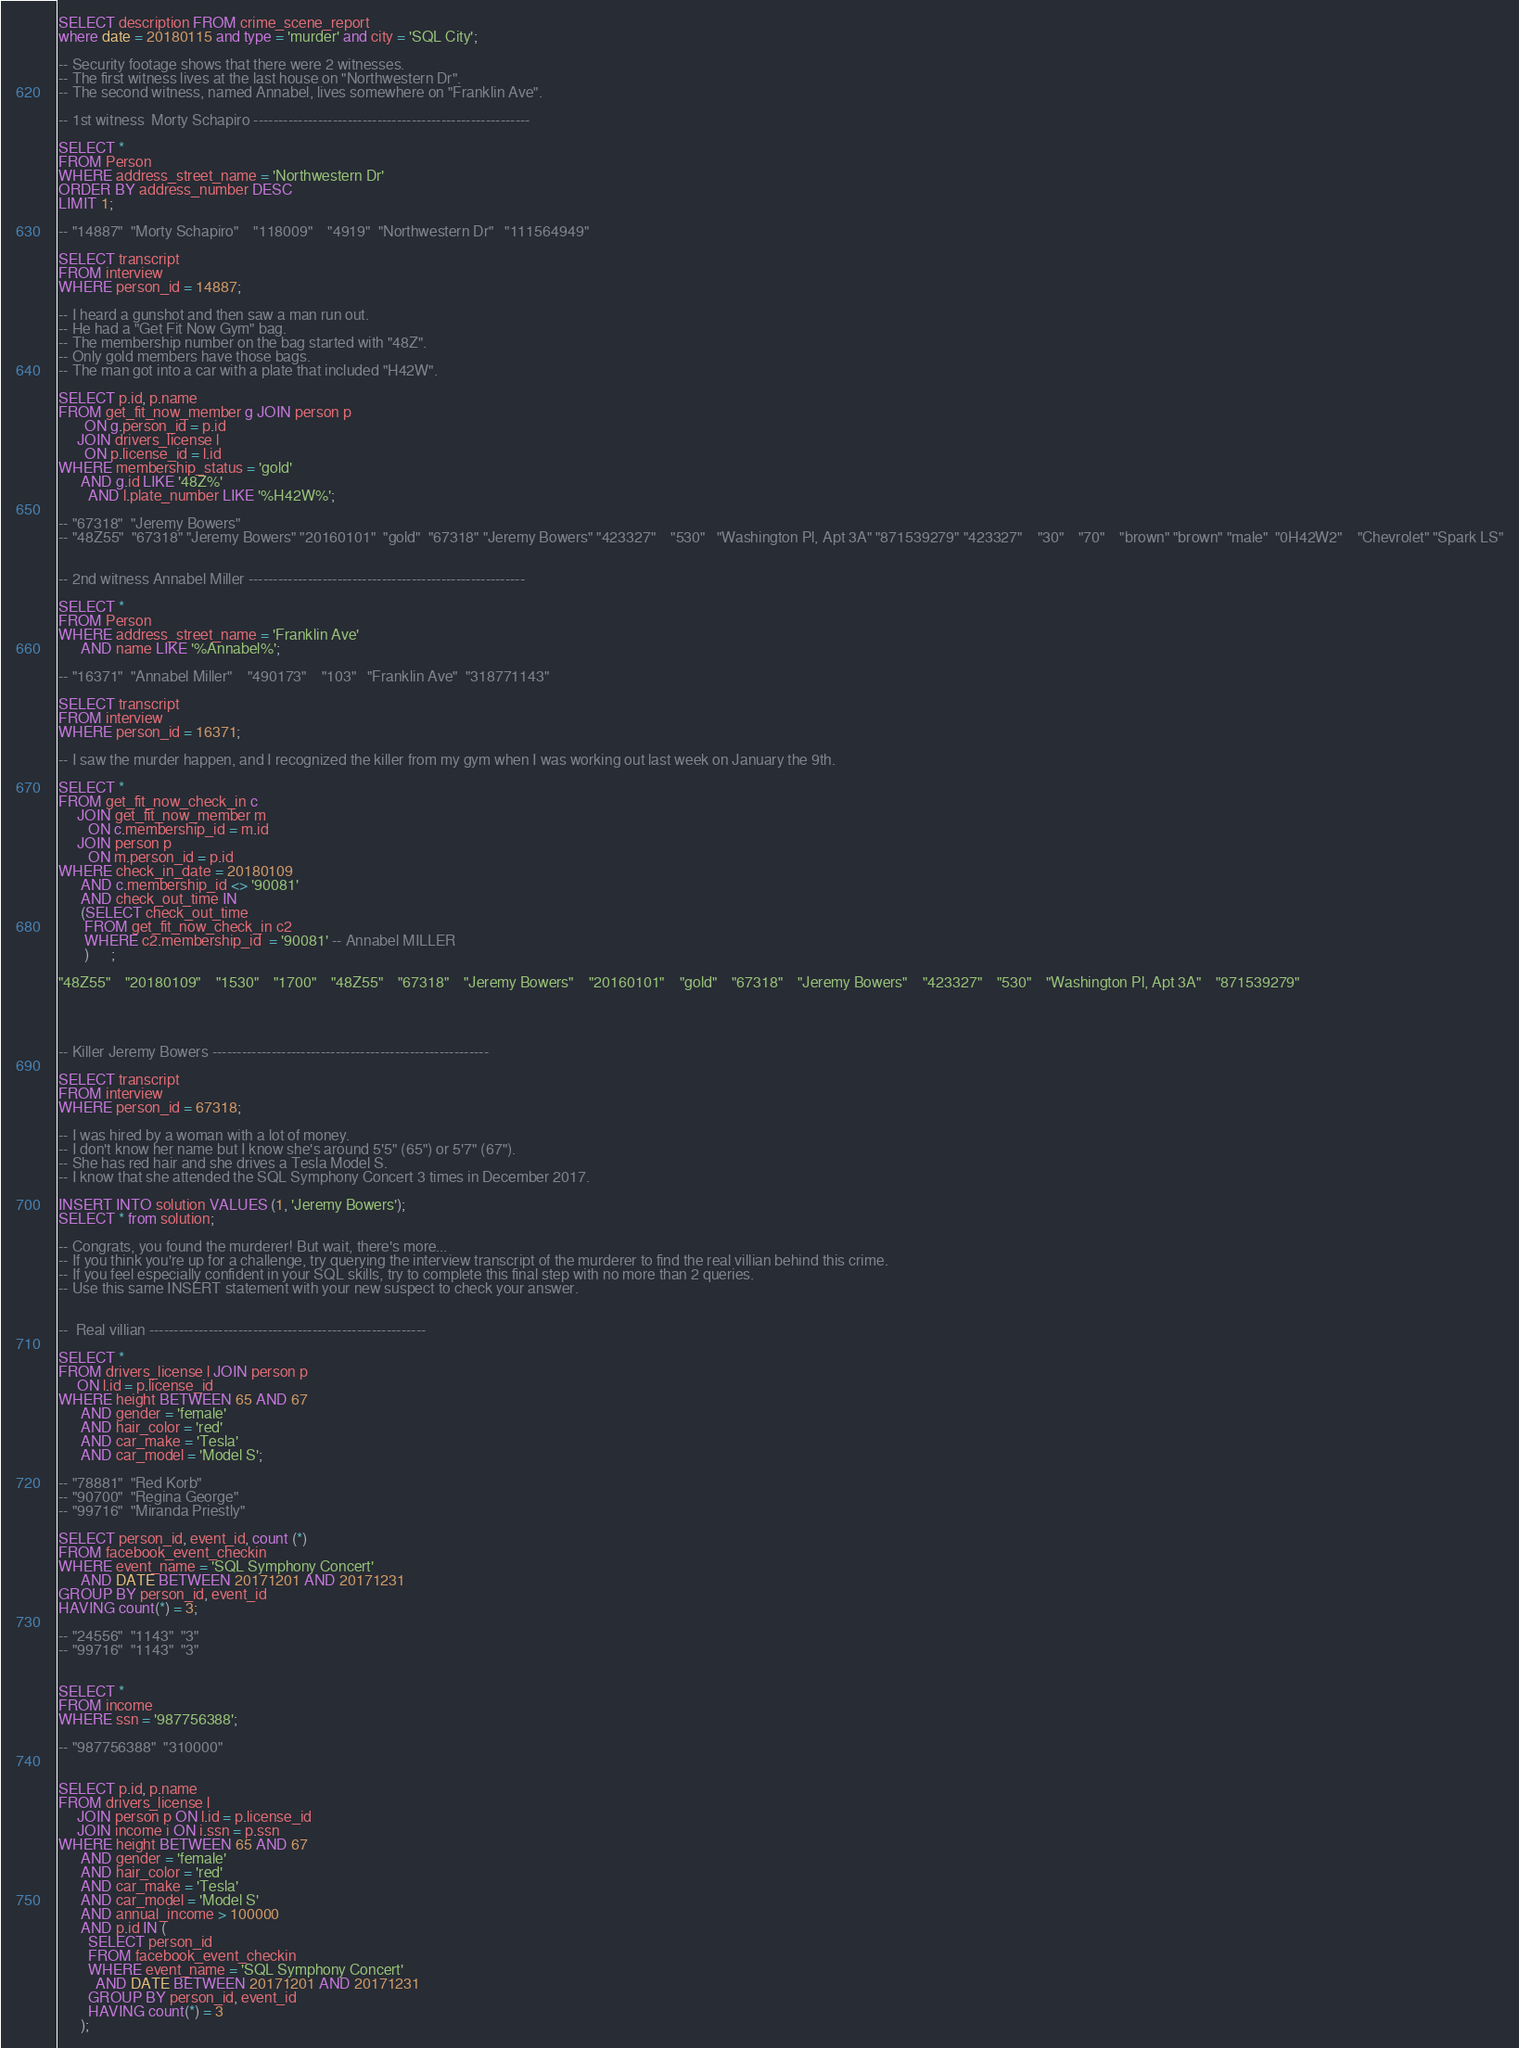<code> <loc_0><loc_0><loc_500><loc_500><_SQL_>SELECT description FROM crime_scene_report
where date = 20180115 and type = 'murder' and city = 'SQL City';

-- Security footage shows that there were 2 witnesses.
-- The first witness lives at the last house on "Northwestern Dr".
-- The second witness, named Annabel, lives somewhere on "Franklin Ave".

-- 1st witness  Morty Schapiro --------------------------------------------------------

SELECT * 
FROM Person
WHERE address_street_name = 'Northwestern Dr'
ORDER BY address_number DESC
LIMIT 1;

-- "14887"	"Morty Schapiro"	"118009"	"4919"	"Northwestern Dr"	"111564949"

SELECT transcript
FROM interview
WHERE person_id = 14887;

-- I heard a gunshot and then saw a man run out.
-- He had a "Get Fit Now Gym" bag.
-- The membership number on the bag started with "48Z".
-- Only gold members have those bags.
-- The man got into a car with a plate that included "H42W".

SELECT p.id, p.name
FROM get_fit_now_member g JOIN person p 
       ON g.person_id = p.id
	 JOIN drivers_license l 
       ON p.license_id = l.id
WHERE membership_status = 'gold'
      AND g.id LIKE '48Z%'
	    AND l.plate_number LIKE '%H42W%';

-- "67318"	"Jeremy Bowers"
-- "48Z55"	"67318"	"Jeremy Bowers"	"20160101"	"gold"	"67318"	"Jeremy Bowers"	"423327"	"530"	"Washington Pl, Apt 3A"	"871539279"	"423327"	"30"	"70"	"brown"	"brown"	"male"	"0H42W2"	"Chevrolet"	"Spark LS"


-- 2nd witness Annabel Miller --------------------------------------------------------

SELECT * 
FROM Person
WHERE address_street_name = 'Franklin Ave'
	  AND name LIKE '%Annabel%';
    
-- "16371"	"Annabel Miller"	"490173"	"103"	"Franklin Ave"	"318771143"

SELECT transcript
FROM interview
WHERE person_id = 16371;

-- I saw the murder happen, and I recognized the killer from my gym when I was working out last week on January the 9th.

SELECT *
FROM get_fit_now_check_in c
     JOIN get_fit_now_member m
		ON c.membership_id = m.id
     JOIN person p 
	    ON m.person_id = p.id
WHERE check_in_date = 20180109
      AND c.membership_id <> '90081'
      AND check_out_time IN 
	  (SELECT check_out_time
	   FROM get_fit_now_check_in c2
	   WHERE c2.membership_id  = '90081' -- Annabel MILLER
	   )	  ;
	
"48Z55"	"20180109"	"1530"	"1700"	"48Z55"	"67318"	"Jeremy Bowers"	"20160101"	"gold"	"67318"	"Jeremy Bowers"	"423327"	"530"	"Washington Pl, Apt 3A"	"871539279"




-- Killer Jeremy Bowers --------------------------------------------------------

SELECT transcript
FROM interview
WHERE person_id = 67318;

-- I was hired by a woman with a lot of money.
-- I don't know her name but I know she's around 5'5" (65") or 5'7" (67").
-- She has red hair and she drives a Tesla Model S.
-- I know that she attended the SQL Symphony Concert 3 times in December 2017.

INSERT INTO solution VALUES (1, 'Jeremy Bowers');
SELECT * from solution;

-- Congrats, you found the murderer! But wait, there's more...
-- If you think you're up for a challenge, try querying the interview transcript of the murderer to find the real villian behind this crime.
-- If you feel especially confident in your SQL skills, try to complete this final step with no more than 2 queries.
-- Use this same INSERT statement with your new suspect to check your answer.


--  Real villian --------------------------------------------------------

SELECT *
FROM drivers_license l JOIN person p
     ON l.id = p.license_id
WHERE height BETWEEN 65 AND 67
      AND gender = 'female'
	  AND hair_color = 'red'
	  AND car_make = 'Tesla'
	  AND car_model = 'Model S';
	  
-- "78881"	"Red Korb"
-- "90700"	"Regina George"
-- "99716"	"Miranda Priestly"

SELECT person_id, event_id, count (*)
FROM facebook_event_checkin
WHERE event_name = 'SQL Symphony Concert'
      AND DATE BETWEEN 20171201 AND 20171231
GROUP BY person_id, event_id
HAVING count(*) = 3;

-- "24556"	"1143"	"3"
-- "99716"	"1143"	"3"


SELECT *
FROM income
WHERE ssn = '987756388';

-- "987756388"	"310000"


SELECT p.id, p.name
FROM drivers_license l
     JOIN person p ON l.id = p.license_id
     JOIN income i ON i.ssn = p.ssn
WHERE height BETWEEN 65 AND 67
      AND gender = 'female'
      AND hair_color = 'red'
      AND car_make = 'Tesla'
      AND car_model = 'Model S'
      AND annual_income > 100000
      AND p.id IN (
        SELECT person_id
        FROM facebook_event_checkin
        WHERE event_name = 'SQL Symphony Concert'
          AND DATE BETWEEN 20171201 AND 20171231
        GROUP BY person_id, event_id
        HAVING count(*) = 3	  
      );
</code> 